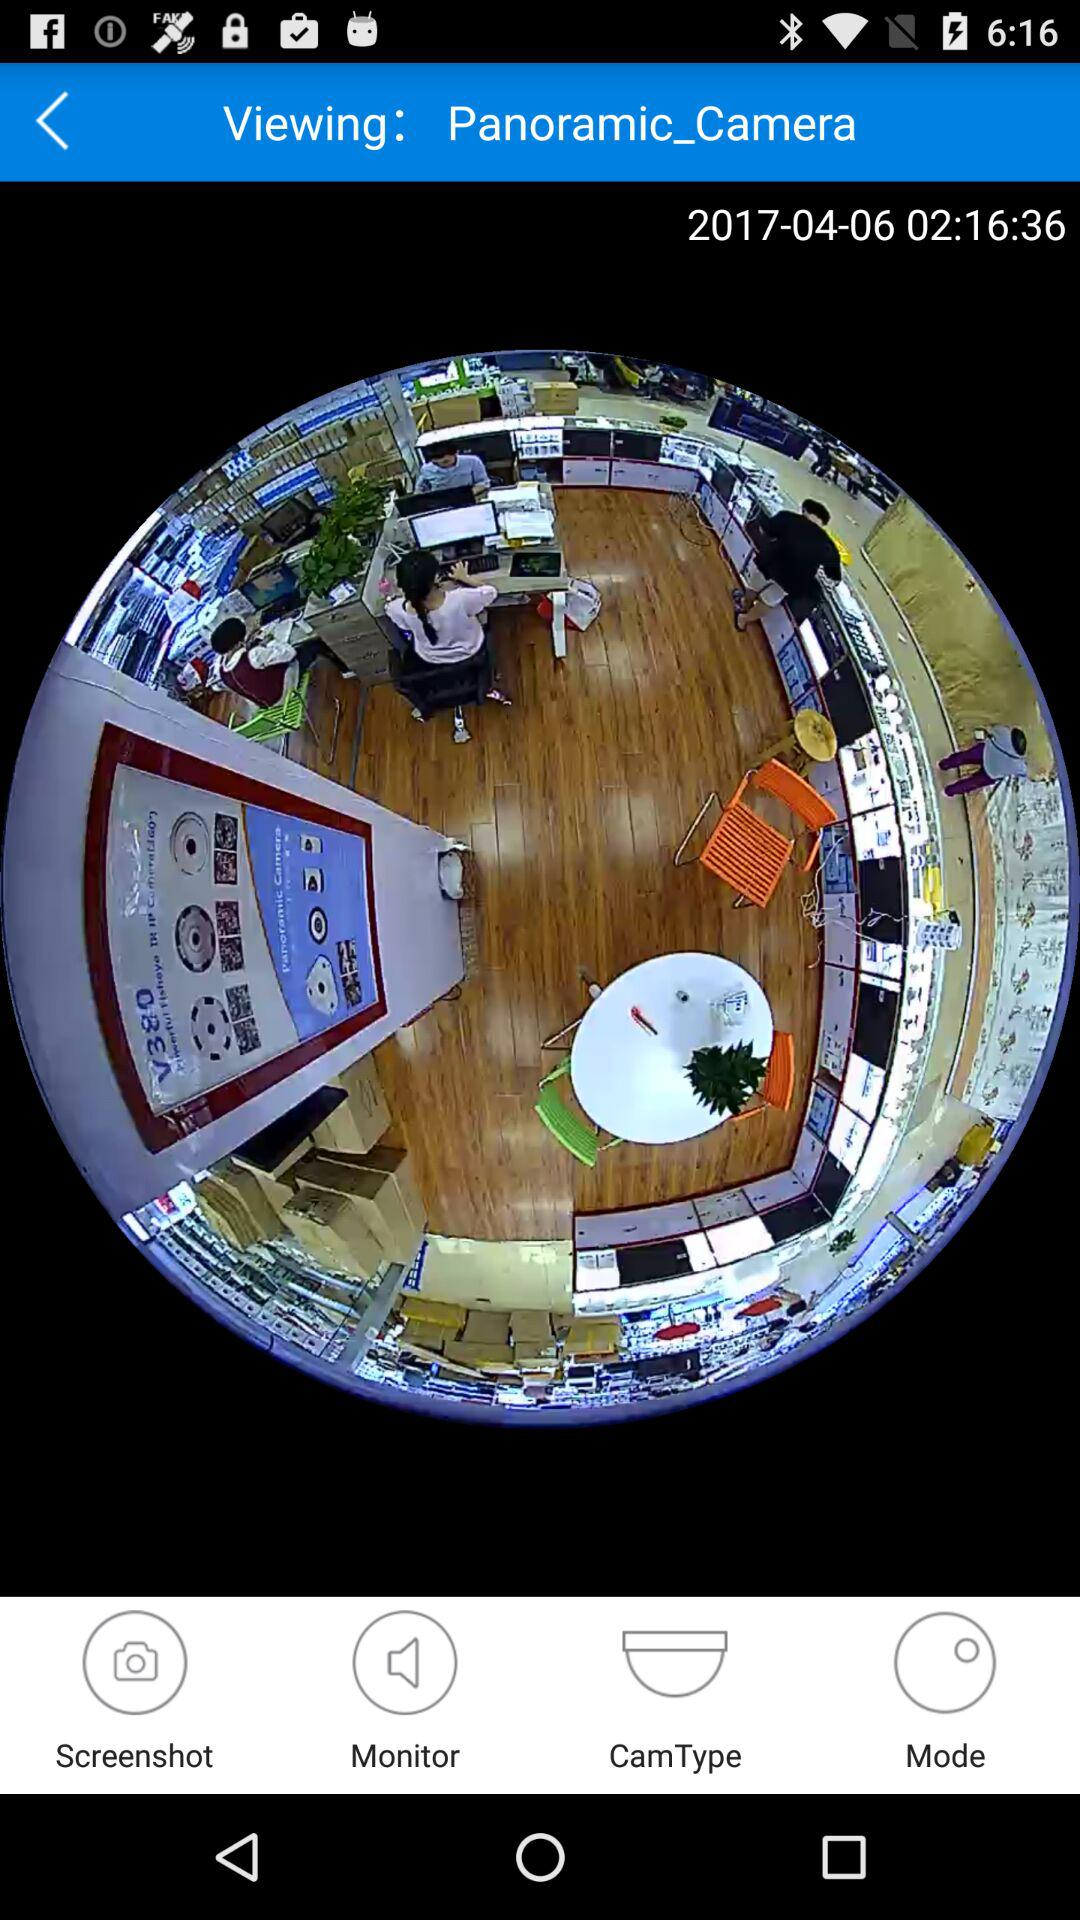How many screenshots are saved?
When the provided information is insufficient, respond with <no answer>. <no answer> 